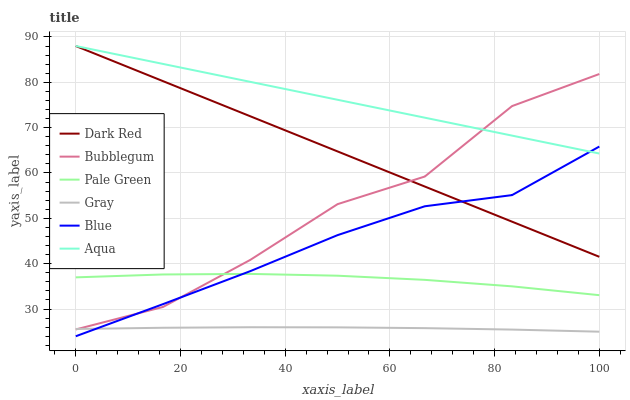Does Gray have the minimum area under the curve?
Answer yes or no. Yes. Does Aqua have the maximum area under the curve?
Answer yes or no. Yes. Does Dark Red have the minimum area under the curve?
Answer yes or no. No. Does Dark Red have the maximum area under the curve?
Answer yes or no. No. Is Dark Red the smoothest?
Answer yes or no. Yes. Is Bubblegum the roughest?
Answer yes or no. Yes. Is Gray the smoothest?
Answer yes or no. No. Is Gray the roughest?
Answer yes or no. No. Does Gray have the lowest value?
Answer yes or no. No. Does Aqua have the highest value?
Answer yes or no. Yes. Does Gray have the highest value?
Answer yes or no. No. Is Pale Green less than Dark Red?
Answer yes or no. Yes. Is Dark Red greater than Gray?
Answer yes or no. Yes. Does Blue intersect Bubblegum?
Answer yes or no. Yes. Is Blue less than Bubblegum?
Answer yes or no. No. Is Blue greater than Bubblegum?
Answer yes or no. No. Does Pale Green intersect Dark Red?
Answer yes or no. No. 